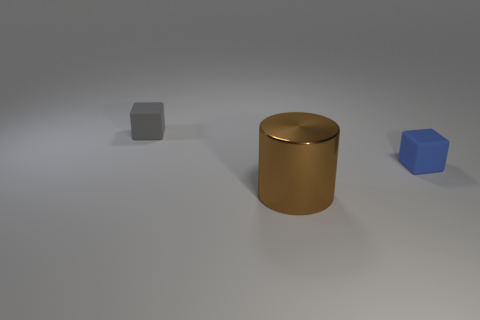What number of other things are there of the same size as the cylinder?
Your response must be concise. 0. What shape is the tiny object on the right side of the small cube behind the small blue matte object?
Offer a very short reply. Cube. There is a cube that is on the left side of the blue object; is its color the same as the block on the right side of the tiny gray object?
Keep it short and to the point. No. Are there any other things of the same color as the metallic thing?
Your response must be concise. No. What is the color of the large metallic cylinder?
Your response must be concise. Brown. Is there a brown cylinder?
Your answer should be compact. Yes. Are there any cubes left of the blue rubber cube?
Your response must be concise. Yes. What material is the tiny gray thing that is the same shape as the tiny blue matte object?
Offer a terse response. Rubber. Is there any other thing that is the same material as the big object?
Your answer should be compact. No. What number of other objects are the same shape as the big object?
Keep it short and to the point. 0. 